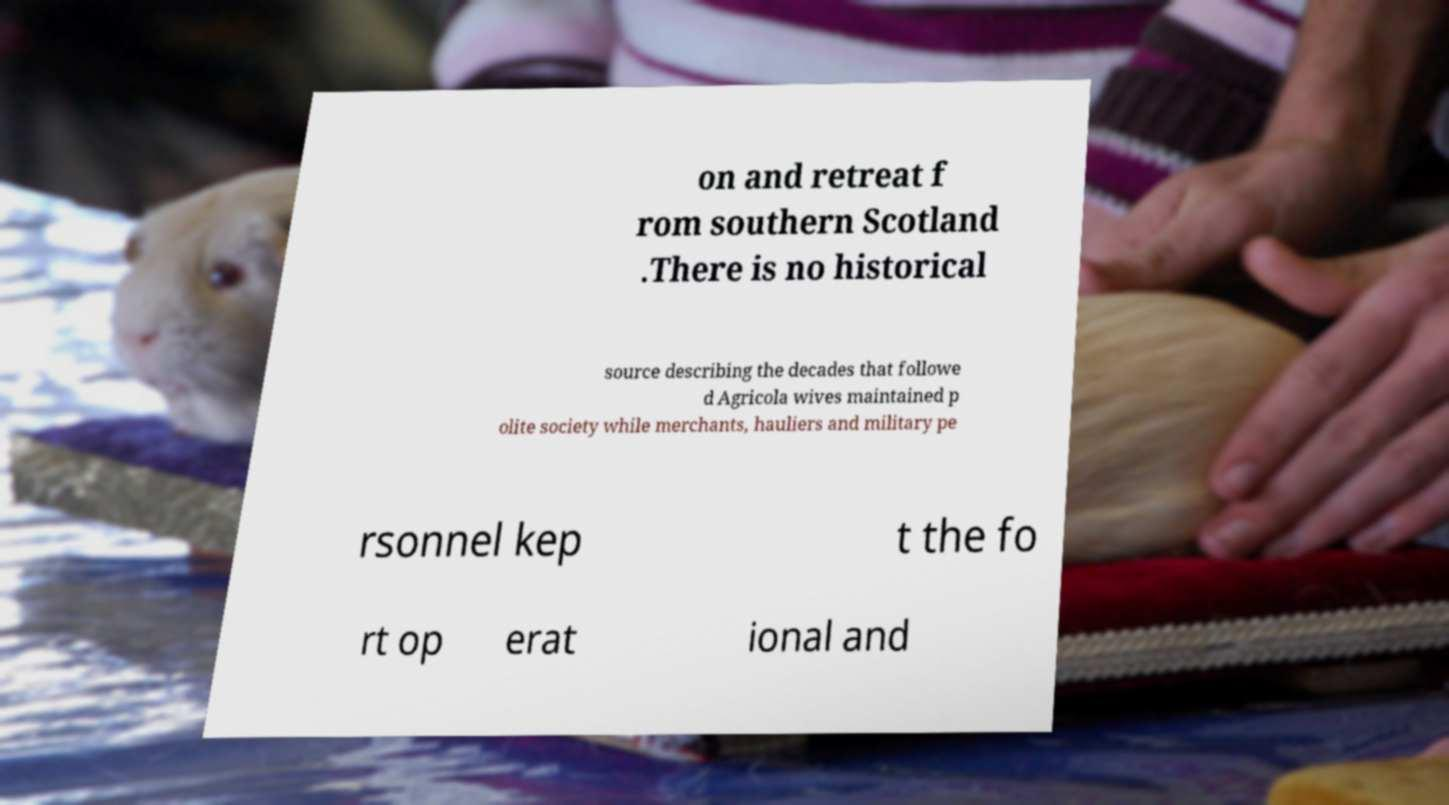For documentation purposes, I need the text within this image transcribed. Could you provide that? on and retreat f rom southern Scotland .There is no historical source describing the decades that followe d Agricola wives maintained p olite society while merchants, hauliers and military pe rsonnel kep t the fo rt op erat ional and 